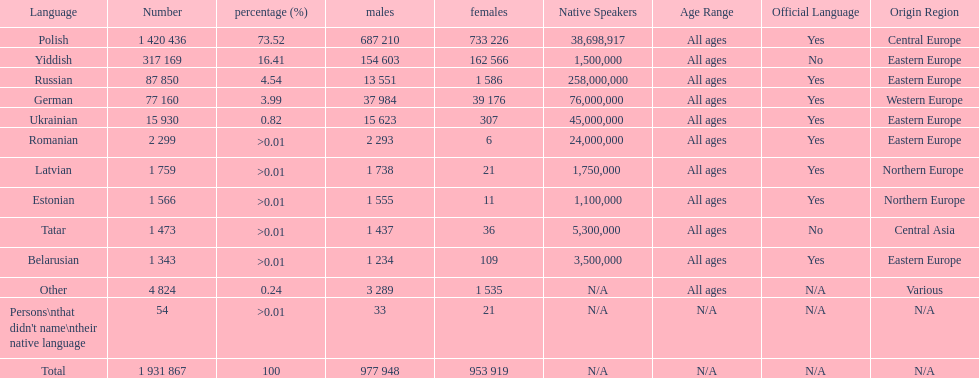Parse the table in full. {'header': ['Language', 'Number', 'percentage (%)', 'males', 'females', 'Native Speakers', 'Age Range', 'Official Language', 'Origin Region'], 'rows': [['Polish', '1 420 436', '73.52', '687 210', '733 226', '38,698,917', 'All ages', 'Yes', 'Central Europe'], ['Yiddish', '317 169', '16.41', '154 603', '162 566', '1,500,000', 'All ages', 'No', 'Eastern Europe'], ['Russian', '87 850', '4.54', '13 551', '1 586', '258,000,000', 'All ages', 'Yes', 'Eastern Europe'], ['German', '77 160', '3.99', '37 984', '39 176', '76,000,000 ', 'All ages', 'Yes', 'Western Europe'], ['Ukrainian', '15 930', '0.82', '15 623', '307', '45,000,000 ', 'All ages', 'Yes', 'Eastern Europe'], ['Romanian', '2 299', '>0.01', '2 293', '6', '24,000,000 ', 'All ages', 'Yes', 'Eastern Europe'], ['Latvian', '1 759', '>0.01', '1 738', '21', '1,750,000 ', 'All ages', 'Yes', 'Northern Europe '], ['Estonian', '1 566', '>0.01', '1 555', '11', '1,100,000', 'All ages', 'Yes', 'Northern Europe'], ['Tatar', '1 473', '>0.01', '1 437', '36', '5,300,000 ', 'All ages', 'No', 'Central Asia'], ['Belarusian', '1 343', '>0.01', '1 234', '109', '3,500,000', 'All ages', 'Yes', 'Eastern Europe'], ['Other', '4 824', '0.24', '3 289', '1 535', 'N/A', 'All ages', 'N/A', 'Various'], ["Persons\\nthat didn't name\\ntheir native language", '54', '>0.01', '33', '21', 'N/A', 'N/A', 'N/A', 'N/A'], ['Total', '1 931 867', '100', '977 948', '953 919', 'N/A', 'N/A', 'N/A', 'N/A']]} Is german above or below russia in the number of people who speak that language? Below. 